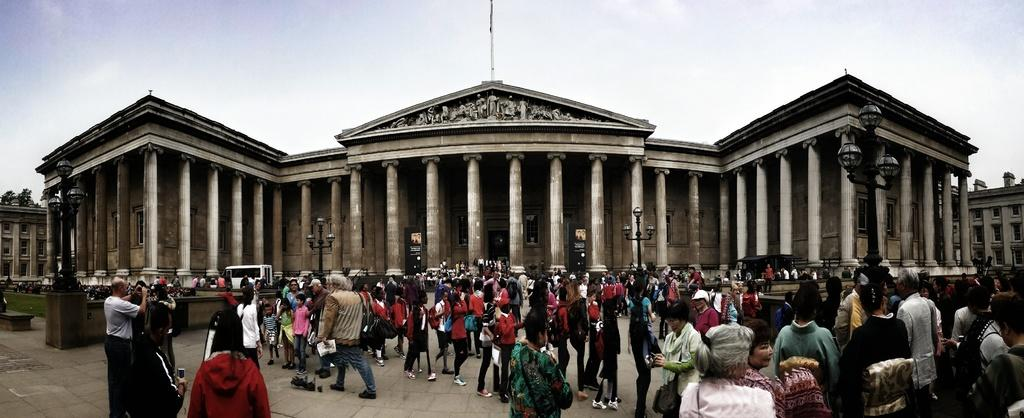What is the main subject in the foreground of the image? There is a crowd in the foreground of the image. What are the people in the crowd doing? The crowd is standing and walking on the ground. What can be seen in the background of the image? There is a building, poles, a vehicle, and the sky visible in the background of the image. What type of writing can be seen on the veil worn by the person in the image? There is no person wearing a veil in the image, and therefore no writing can be observed. 